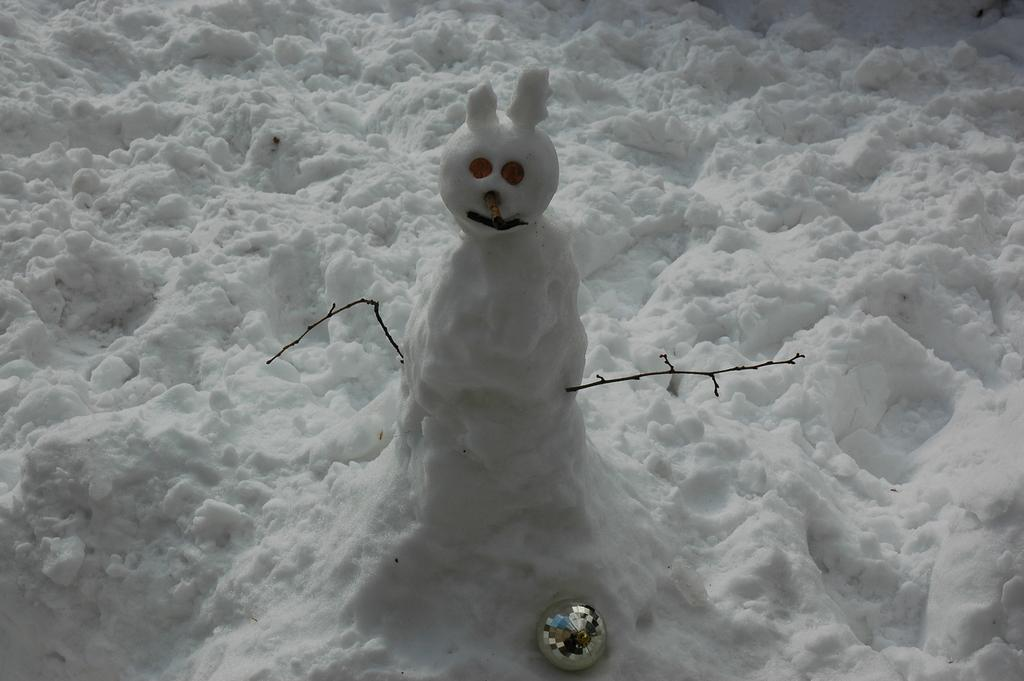What is the main subject of the image? There is a snowman in the image. What is the snowman made of? The snowman is made of ice. What other object can be seen in the image? There is a ball visible in the image. What is the general theme of the image? The image has a winter theme, as there is ice present in the image. How many ladybugs can be seen crawling on the snowman in the image? There are no ladybugs present in the image; the snowman is made of ice and is not a suitable habitat for ladybugs. 